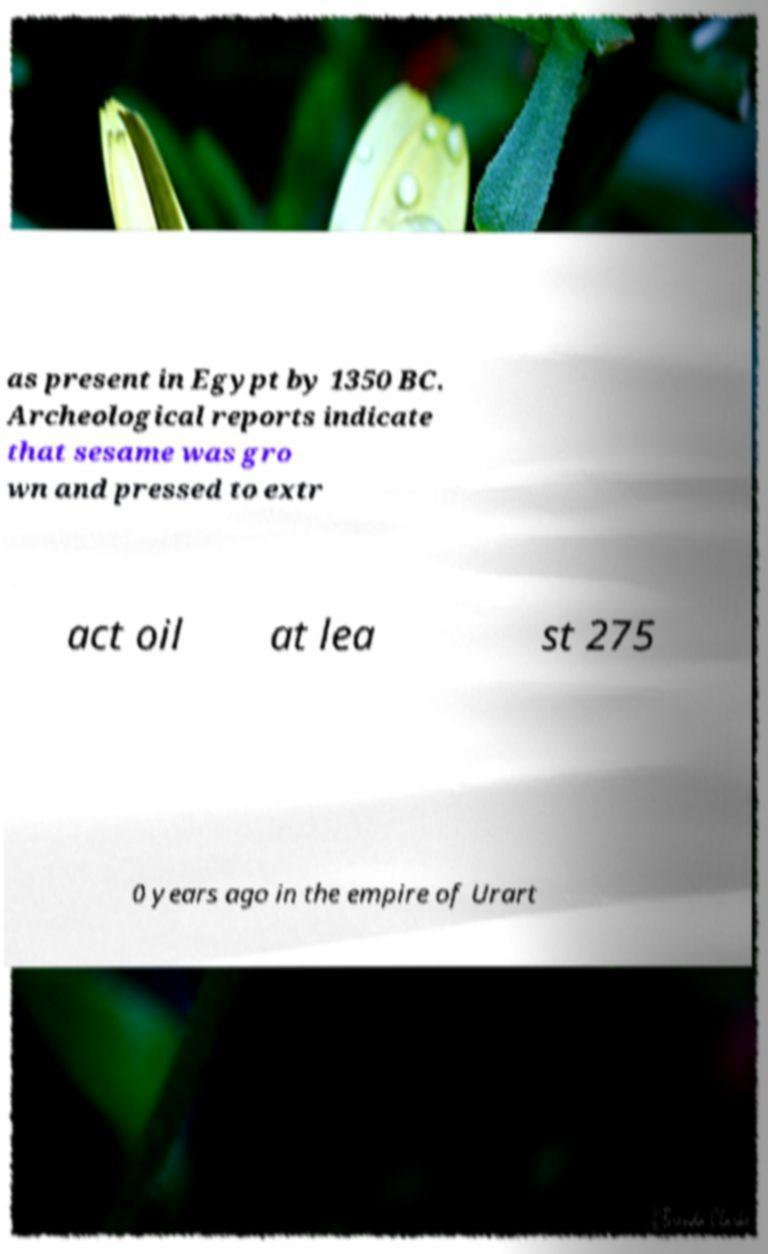Please identify and transcribe the text found in this image. as present in Egypt by 1350 BC. Archeological reports indicate that sesame was gro wn and pressed to extr act oil at lea st 275 0 years ago in the empire of Urart 